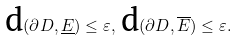<formula> <loc_0><loc_0><loc_500><loc_500>\text {d} ( \partial D , \underline { E } ) \leq \varepsilon , \, \text {d} ( \partial D , \overline { E } ) \leq \varepsilon .</formula> 